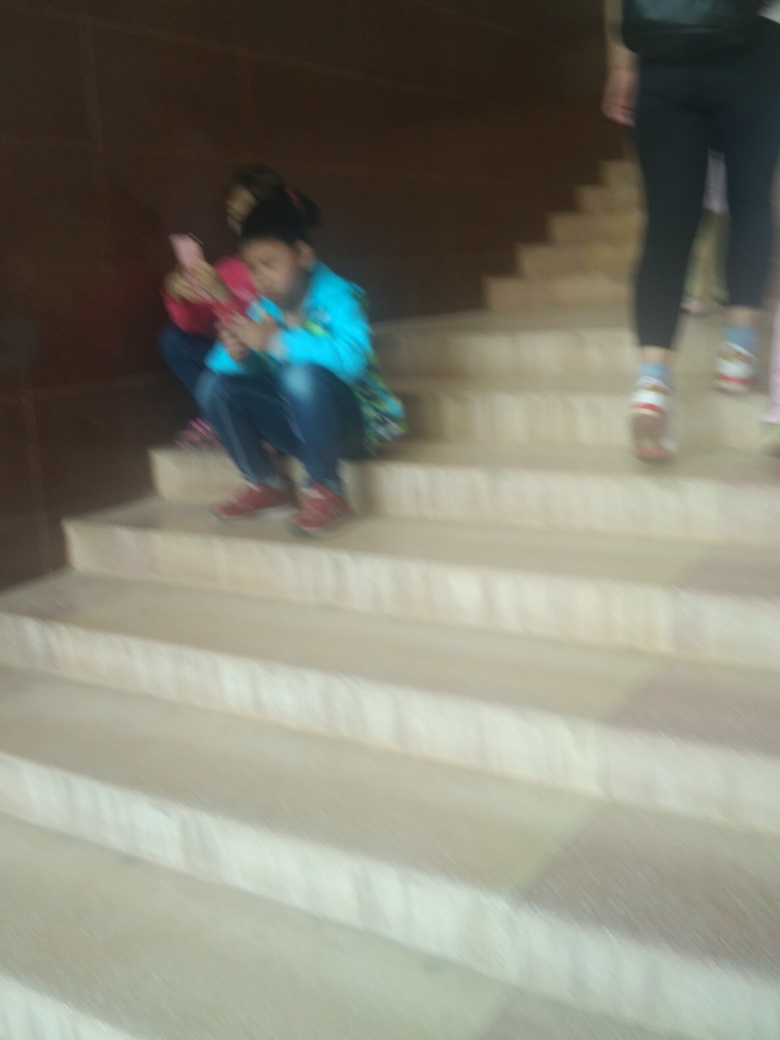What are the subjects doing in the image? The subjects seem to be seated on steps, potentially engaging with electronic devices or interacting with each other, suggesting a moment of casual rest or digital interaction. 